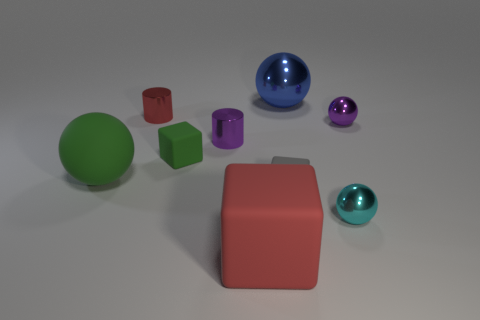Subtract 1 spheres. How many spheres are left? 3 Add 1 small cyan shiny balls. How many objects exist? 10 Subtract all balls. How many objects are left? 5 Add 2 rubber things. How many rubber things exist? 6 Subtract 1 gray blocks. How many objects are left? 8 Subtract all large yellow rubber blocks. Subtract all tiny matte things. How many objects are left? 7 Add 9 big blue things. How many big blue things are left? 10 